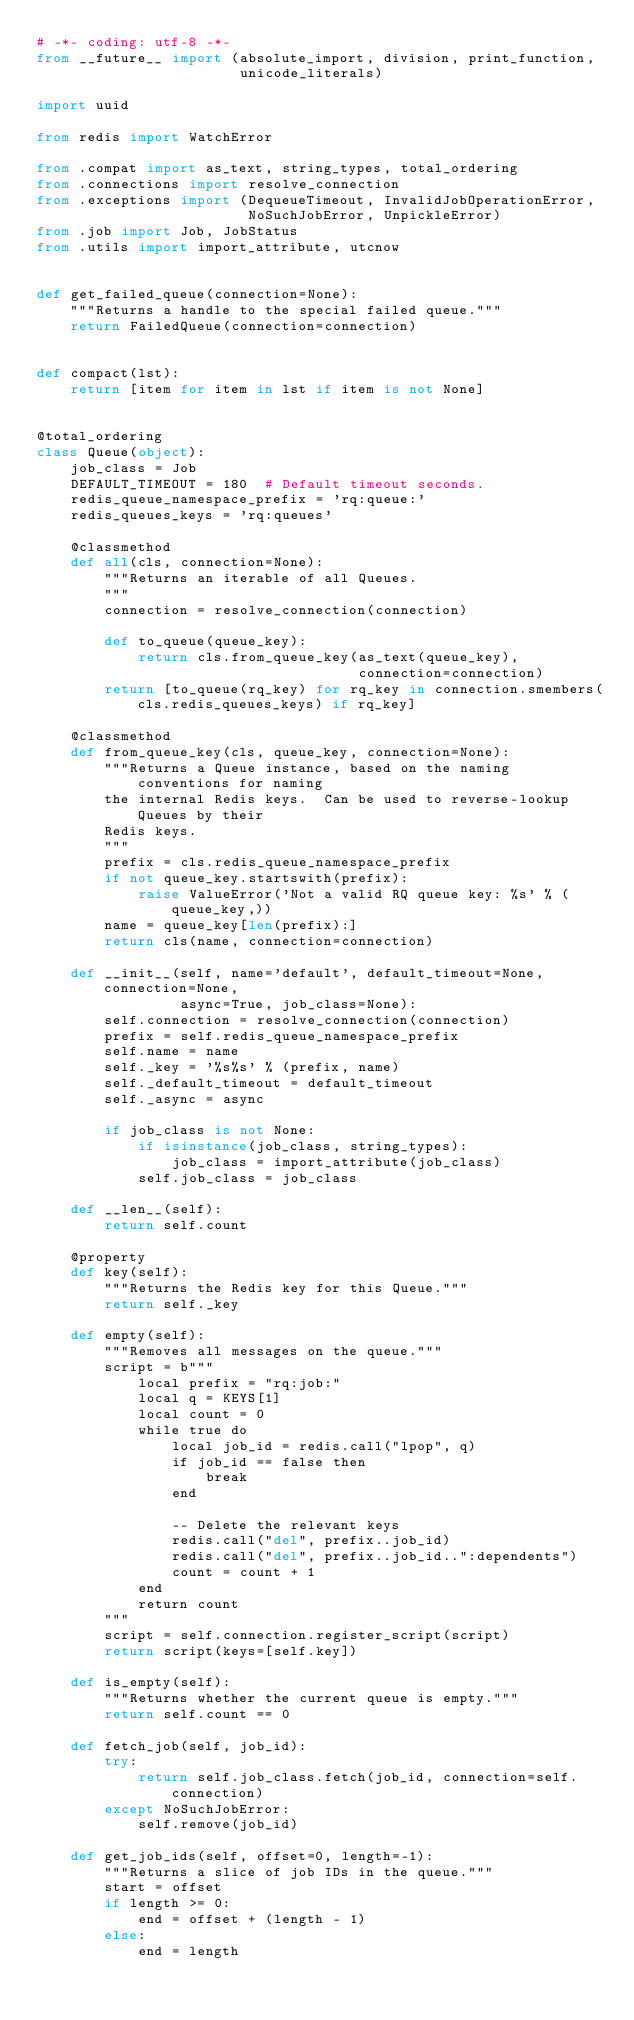Convert code to text. <code><loc_0><loc_0><loc_500><loc_500><_Python_># -*- coding: utf-8 -*-
from __future__ import (absolute_import, division, print_function,
                        unicode_literals)

import uuid

from redis import WatchError

from .compat import as_text, string_types, total_ordering
from .connections import resolve_connection
from .exceptions import (DequeueTimeout, InvalidJobOperationError,
                         NoSuchJobError, UnpickleError)
from .job import Job, JobStatus
from .utils import import_attribute, utcnow


def get_failed_queue(connection=None):
    """Returns a handle to the special failed queue."""
    return FailedQueue(connection=connection)


def compact(lst):
    return [item for item in lst if item is not None]


@total_ordering
class Queue(object):
    job_class = Job
    DEFAULT_TIMEOUT = 180  # Default timeout seconds.
    redis_queue_namespace_prefix = 'rq:queue:'
    redis_queues_keys = 'rq:queues'

    @classmethod
    def all(cls, connection=None):
        """Returns an iterable of all Queues.
        """
        connection = resolve_connection(connection)

        def to_queue(queue_key):
            return cls.from_queue_key(as_text(queue_key),
                                      connection=connection)
        return [to_queue(rq_key) for rq_key in connection.smembers(cls.redis_queues_keys) if rq_key]

    @classmethod
    def from_queue_key(cls, queue_key, connection=None):
        """Returns a Queue instance, based on the naming conventions for naming
        the internal Redis keys.  Can be used to reverse-lookup Queues by their
        Redis keys.
        """
        prefix = cls.redis_queue_namespace_prefix
        if not queue_key.startswith(prefix):
            raise ValueError('Not a valid RQ queue key: %s' % (queue_key,))
        name = queue_key[len(prefix):]
        return cls(name, connection=connection)

    def __init__(self, name='default', default_timeout=None, connection=None,
                 async=True, job_class=None):
        self.connection = resolve_connection(connection)
        prefix = self.redis_queue_namespace_prefix
        self.name = name
        self._key = '%s%s' % (prefix, name)
        self._default_timeout = default_timeout
        self._async = async

        if job_class is not None:
            if isinstance(job_class, string_types):
                job_class = import_attribute(job_class)
            self.job_class = job_class

    def __len__(self):
        return self.count

    @property
    def key(self):
        """Returns the Redis key for this Queue."""
        return self._key

    def empty(self):
        """Removes all messages on the queue."""
        script = b"""
            local prefix = "rq:job:"
            local q = KEYS[1]
            local count = 0
            while true do
                local job_id = redis.call("lpop", q)
                if job_id == false then
                    break
                end

                -- Delete the relevant keys
                redis.call("del", prefix..job_id)
                redis.call("del", prefix..job_id..":dependents")
                count = count + 1
            end
            return count
        """
        script = self.connection.register_script(script)
        return script(keys=[self.key])

    def is_empty(self):
        """Returns whether the current queue is empty."""
        return self.count == 0

    def fetch_job(self, job_id):
        try:
            return self.job_class.fetch(job_id, connection=self.connection)
        except NoSuchJobError:
            self.remove(job_id)

    def get_job_ids(self, offset=0, length=-1):
        """Returns a slice of job IDs in the queue."""
        start = offset
        if length >= 0:
            end = offset + (length - 1)
        else:
            end = length</code> 